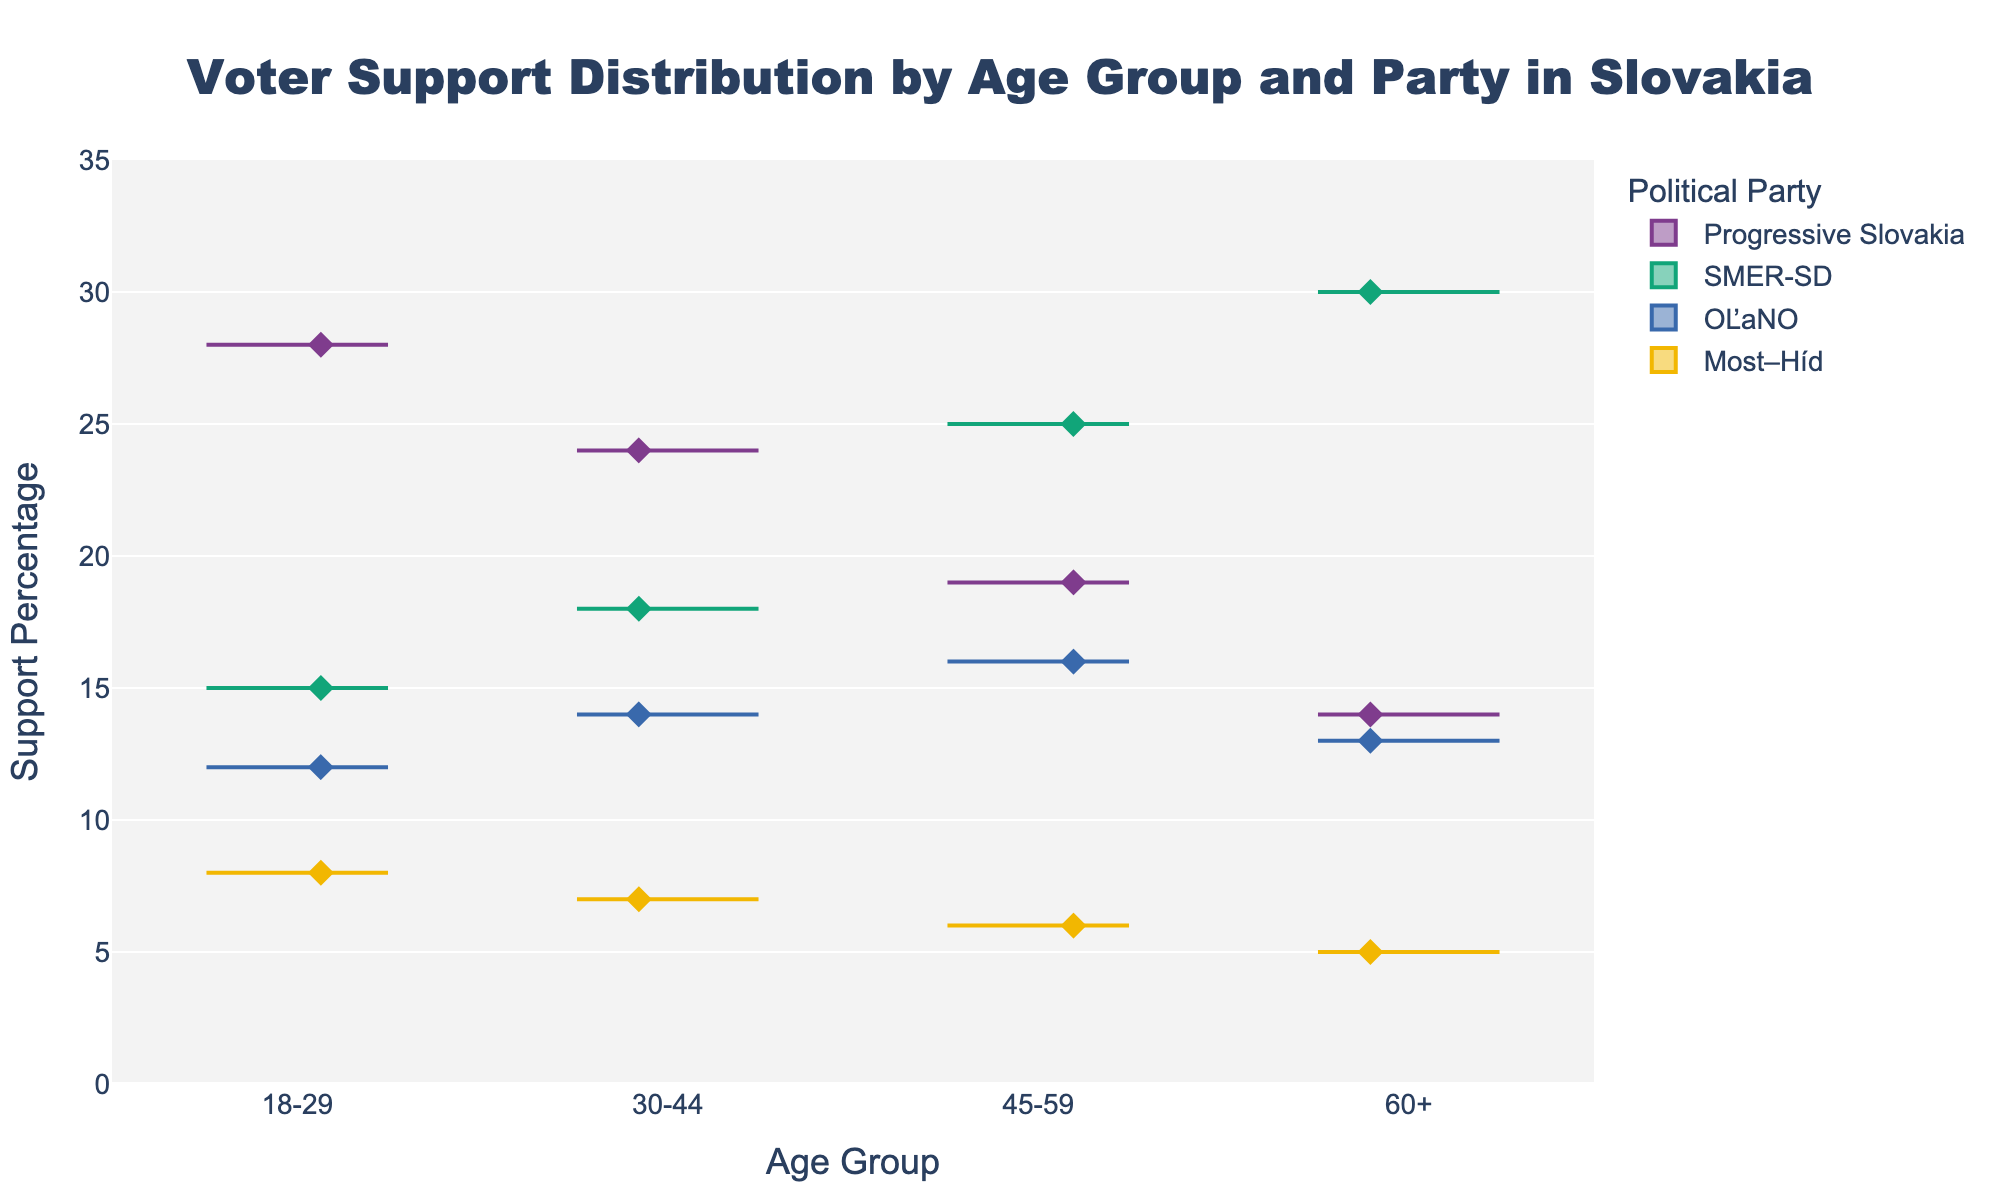What is the title of the figure? The title is located at the top of the figure and is usually in a larger, bold font to make it easily distinguishable. It provides a concise description of the figure's content.
Answer: Voter Support Distribution by Age Group and Party in Slovakia What are the age groups represented on the x-axis? Looking at the bottom of the figure along the horizontal axis (x-axis), you can see the labels for different age groups.
Answer: 18-29, 30-44, 45-59, 60+ Which party has the largest support percentage in the 18-29 age group? To find the answer, look at the clusters of points (strip plots) corresponding to the 18-29 age group on the figure. Observe the 'Support Percentage' values for each political party in this group.
Answer: Progressive Slovakia How does the support for SMER-SD change across age groups? Trace the box plots for SMER-SD across all the age groups (18-29, 30-44, 45-59, 60+). Note the trend in the height of the boxes or individual points.
Answer: It increases Which age group shows the smallest support percentage for Most–Híd? Examine the distribution of points for Most–Híd across all age groups. Identify which age group has the lowest points.
Answer: 60+ What is the difference in support percentage between SMER-SD and Progressive Slovakia in the 45-59 age group? Find the support percentage points for both SMER-SD and Progressive Slovakia within the 45-59 age group by looking at their respective boxes. Subtract the support percentage of Progressive Slovakia from that of SMER-SD.
Answer: 6% Among all parties, which one shows the largest variation in support percentages across different age groups? Variation in support percentages can be observed by comparing the range of values (height of the boxes) for each party across different age groups. Identify the party with the widest range.
Answer: Progressive Slovakia Which party has the most consistent support percentage across age groups? Consistency can be assessed by observing the tightness or the minimal range of support percentages for each party across all age groups. Find the party with the least spread of values.
Answer: Most–Híd In which age group does OĽaNO have its highest support percentage? Look for the highest points or parts of the box plot for OĽaNO across the different age groups and identify the corresponding age group with the maximum value.
Answer: 45-59 